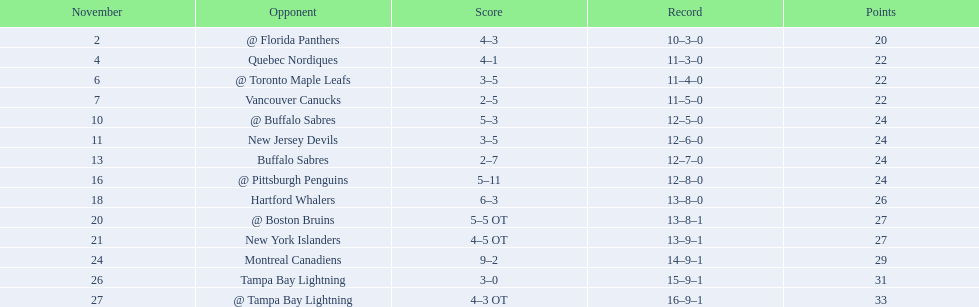What were the scores? @ Florida Panthers, 4–3, Quebec Nordiques, 4–1, @ Toronto Maple Leafs, 3–5, Vancouver Canucks, 2–5, @ Buffalo Sabres, 5–3, New Jersey Devils, 3–5, Buffalo Sabres, 2–7, @ Pittsburgh Penguins, 5–11, Hartford Whalers, 6–3, @ Boston Bruins, 5–5 OT, New York Islanders, 4–5 OT, Montreal Canadiens, 9–2, Tampa Bay Lightning, 3–0, @ Tampa Bay Lightning, 4–3 OT. What score was the closest? New York Islanders, 4–5 OT. What team had that score? New York Islanders. 